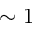Convert formula to latex. <formula><loc_0><loc_0><loc_500><loc_500>\sim 1</formula> 